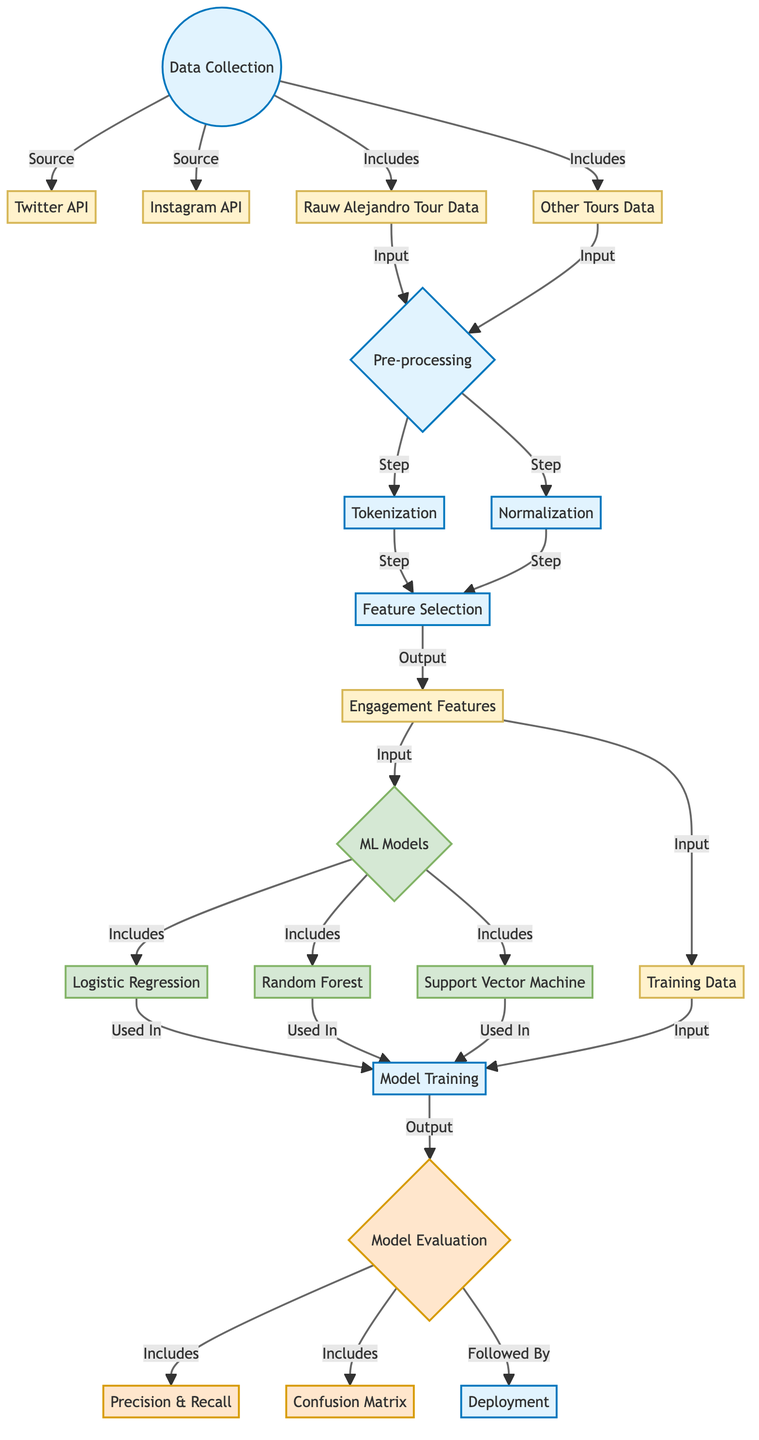What are the data sources for data collection? The diagram indicates that the sources for data collection are the Twitter API and Instagram API. They are specifically labeled under the "Data Collection" process node.
Answer: Twitter API and Instagram API What does the feature selection output into? The output of feature selection is labeled as "Engagement Features" in the diagram. It is the result of the pre-processing step that includes tokenization and normalization.
Answer: Engagement Features How many ML models are included in this diagram? The diagram shows three machine learning models: Logistic Regression, Random Forest, and Support Vector Machine. They are grouped under the "ML Models" node.
Answer: Three Which process follows model evaluation? According to the diagram, the process that follows model evaluation is labeled as "Deployment." It shows the final step after evaluating the models' performance through precision, recall, and confusion matrix.
Answer: Deployment What is the first step taken after data collection? The first step taken after data collection is "Pre-processing." This node follows the data collection node and includes tokenization and normalization as its subsequent steps.
Answer: Pre-processing What do the precision and recall metrics relate to? Precision and recall metrics are part of the "Model Evaluation" process. They are indicated as components that are evaluated after model training has been completed.
Answer: Model Evaluation What is the connection between engagement features and ML models? The connection is that engagement features serve as input for the ML models, which consist of Logistic Regression, Random Forest, and Support Vector Machine. This is a key part of the data flow in the diagram.
Answer: Input What type of diagram is this? This is a machine learning diagram that outlines the process of classifying fan engagement levels from social media interactions. The components, relationships, and flow are specific to machine learning methodologies.
Answer: Machine Learning Diagram 